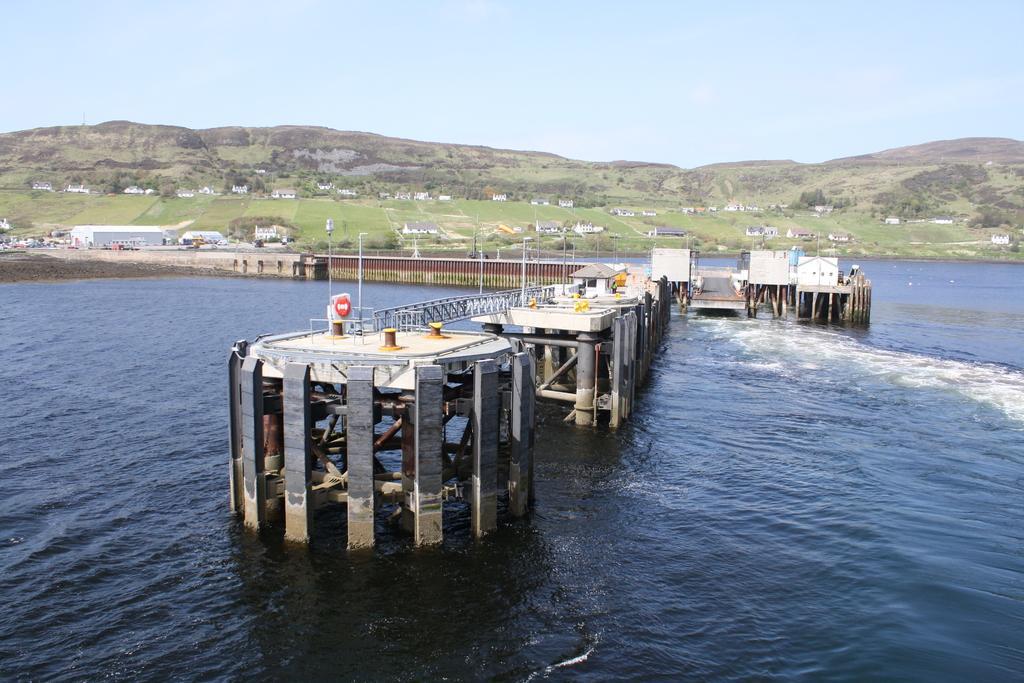Please provide a concise description of this image. In this image we can see a bridge in the water. And there are houses, trees, grass, mountains and sky in the background. 